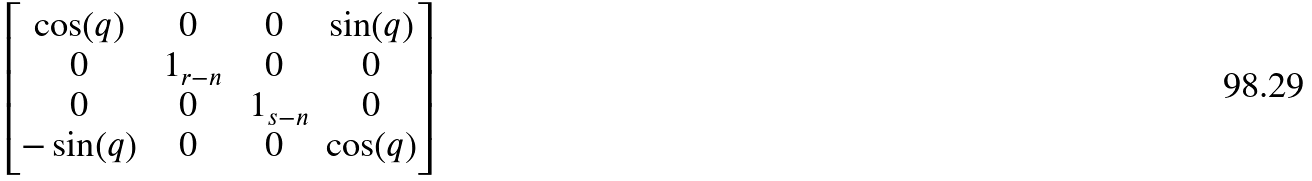Convert formula to latex. <formula><loc_0><loc_0><loc_500><loc_500>\begin{bmatrix} \cos ( q ) & 0 & 0 & \sin ( q ) \\ 0 & \ 1 _ { r - n } & 0 & 0 \\ 0 & 0 & \ 1 _ { s - n } & 0 \\ - \sin ( q ) & 0 & 0 & \cos ( q ) \end{bmatrix}</formula> 